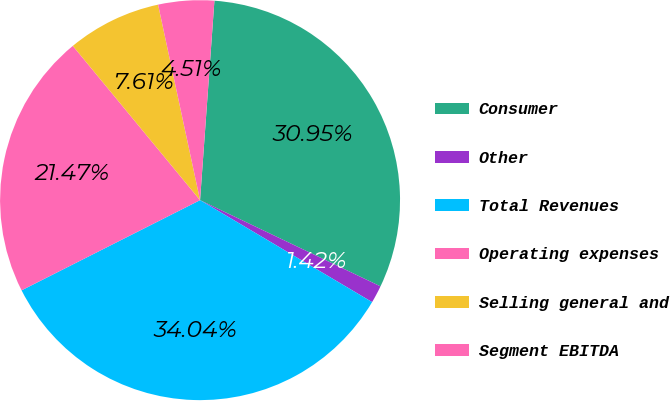<chart> <loc_0><loc_0><loc_500><loc_500><pie_chart><fcel>Consumer<fcel>Other<fcel>Total Revenues<fcel>Operating expenses<fcel>Selling general and<fcel>Segment EBITDA<nl><fcel>30.95%<fcel>1.42%<fcel>34.04%<fcel>21.47%<fcel>7.61%<fcel>4.51%<nl></chart> 